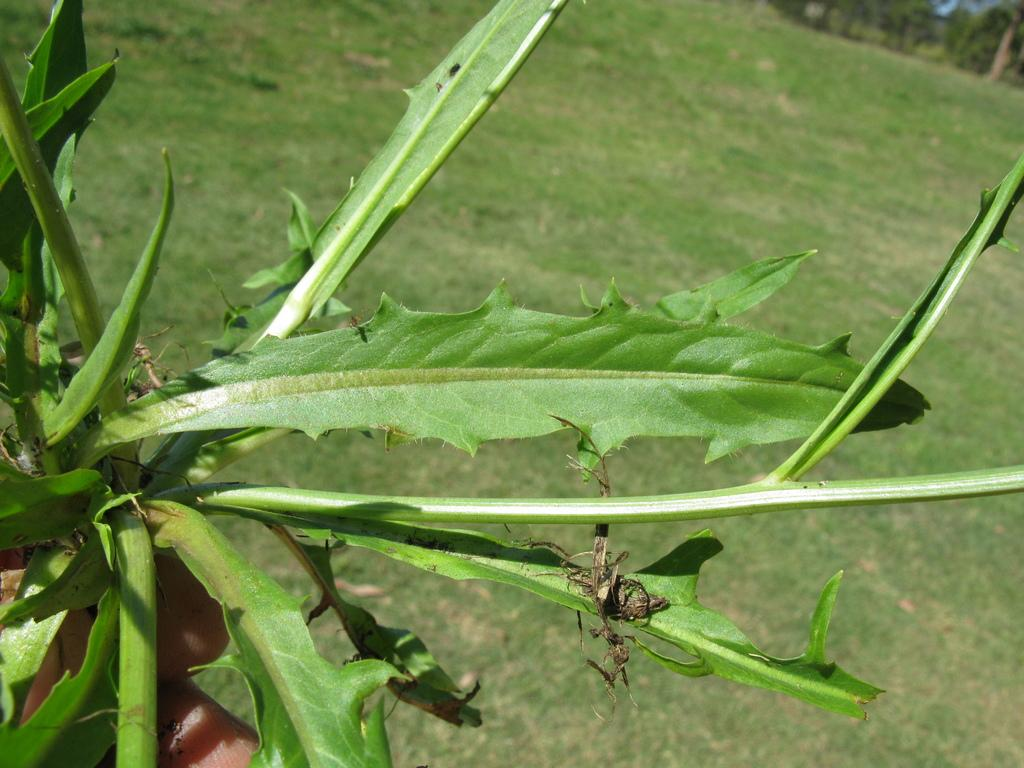What is the person in the image holding? The person is holding a plant in the image. What type of vegetation can be seen in the background of the image? There are trees visible at the back of the image. What is the ground made of in the image? The ground is covered with grass in the image. Where is the toothbrush located in the image? There is no toothbrush present in the image. How many cakes are visible in the image? There are no cakes visible in the image. 